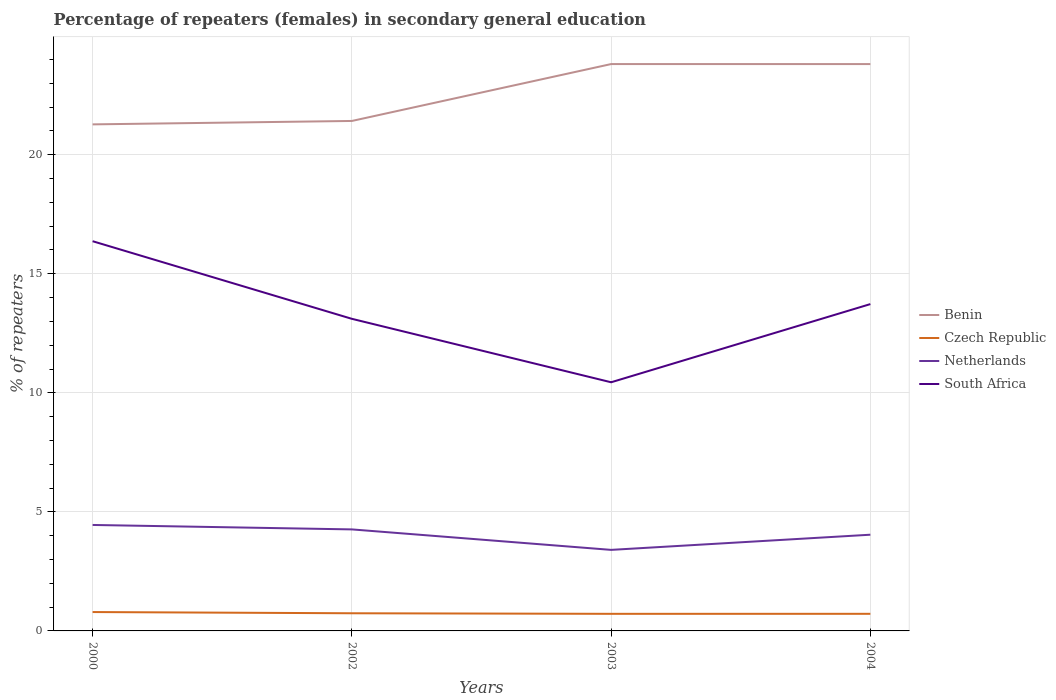Does the line corresponding to Benin intersect with the line corresponding to Netherlands?
Your answer should be compact. No. Across all years, what is the maximum percentage of female repeaters in Benin?
Provide a succinct answer. 21.28. In which year was the percentage of female repeaters in Czech Republic maximum?
Provide a short and direct response. 2003. What is the total percentage of female repeaters in Netherlands in the graph?
Your answer should be compact. 0.22. What is the difference between the highest and the second highest percentage of female repeaters in South Africa?
Keep it short and to the point. 5.93. What is the difference between the highest and the lowest percentage of female repeaters in Netherlands?
Your answer should be compact. 3. How many lines are there?
Offer a very short reply. 4. How many years are there in the graph?
Offer a very short reply. 4. Are the values on the major ticks of Y-axis written in scientific E-notation?
Offer a terse response. No. Where does the legend appear in the graph?
Provide a succinct answer. Center right. How many legend labels are there?
Give a very brief answer. 4. What is the title of the graph?
Your answer should be compact. Percentage of repeaters (females) in secondary general education. What is the label or title of the Y-axis?
Make the answer very short. % of repeaters. What is the % of repeaters in Benin in 2000?
Your answer should be very brief. 21.28. What is the % of repeaters of Czech Republic in 2000?
Provide a succinct answer. 0.79. What is the % of repeaters in Netherlands in 2000?
Your answer should be compact. 4.45. What is the % of repeaters of South Africa in 2000?
Make the answer very short. 16.37. What is the % of repeaters of Benin in 2002?
Provide a succinct answer. 21.42. What is the % of repeaters in Czech Republic in 2002?
Make the answer very short. 0.74. What is the % of repeaters in Netherlands in 2002?
Give a very brief answer. 4.26. What is the % of repeaters of South Africa in 2002?
Ensure brevity in your answer.  13.11. What is the % of repeaters of Benin in 2003?
Your answer should be compact. 23.81. What is the % of repeaters of Czech Republic in 2003?
Your answer should be very brief. 0.72. What is the % of repeaters in Netherlands in 2003?
Provide a short and direct response. 3.4. What is the % of repeaters of South Africa in 2003?
Ensure brevity in your answer.  10.44. What is the % of repeaters in Benin in 2004?
Provide a short and direct response. 23.81. What is the % of repeaters of Czech Republic in 2004?
Provide a succinct answer. 0.72. What is the % of repeaters in Netherlands in 2004?
Ensure brevity in your answer.  4.04. What is the % of repeaters of South Africa in 2004?
Make the answer very short. 13.73. Across all years, what is the maximum % of repeaters in Benin?
Keep it short and to the point. 23.81. Across all years, what is the maximum % of repeaters in Czech Republic?
Offer a terse response. 0.79. Across all years, what is the maximum % of repeaters of Netherlands?
Your answer should be very brief. 4.45. Across all years, what is the maximum % of repeaters in South Africa?
Your response must be concise. 16.37. Across all years, what is the minimum % of repeaters in Benin?
Give a very brief answer. 21.28. Across all years, what is the minimum % of repeaters of Czech Republic?
Ensure brevity in your answer.  0.72. Across all years, what is the minimum % of repeaters in Netherlands?
Provide a short and direct response. 3.4. Across all years, what is the minimum % of repeaters in South Africa?
Your response must be concise. 10.44. What is the total % of repeaters in Benin in the graph?
Provide a short and direct response. 90.31. What is the total % of repeaters in Czech Republic in the graph?
Give a very brief answer. 2.97. What is the total % of repeaters in Netherlands in the graph?
Provide a succinct answer. 16.16. What is the total % of repeaters of South Africa in the graph?
Your response must be concise. 53.65. What is the difference between the % of repeaters of Benin in 2000 and that in 2002?
Provide a short and direct response. -0.14. What is the difference between the % of repeaters in Czech Republic in 2000 and that in 2002?
Provide a succinct answer. 0.05. What is the difference between the % of repeaters in Netherlands in 2000 and that in 2002?
Your response must be concise. 0.19. What is the difference between the % of repeaters of South Africa in 2000 and that in 2002?
Your answer should be very brief. 3.26. What is the difference between the % of repeaters in Benin in 2000 and that in 2003?
Provide a succinct answer. -2.53. What is the difference between the % of repeaters in Czech Republic in 2000 and that in 2003?
Ensure brevity in your answer.  0.07. What is the difference between the % of repeaters of Netherlands in 2000 and that in 2003?
Offer a terse response. 1.05. What is the difference between the % of repeaters in South Africa in 2000 and that in 2003?
Ensure brevity in your answer.  5.93. What is the difference between the % of repeaters of Benin in 2000 and that in 2004?
Your answer should be compact. -2.53. What is the difference between the % of repeaters of Czech Republic in 2000 and that in 2004?
Offer a terse response. 0.07. What is the difference between the % of repeaters in Netherlands in 2000 and that in 2004?
Make the answer very short. 0.41. What is the difference between the % of repeaters of South Africa in 2000 and that in 2004?
Your response must be concise. 2.64. What is the difference between the % of repeaters of Benin in 2002 and that in 2003?
Keep it short and to the point. -2.39. What is the difference between the % of repeaters of Czech Republic in 2002 and that in 2003?
Your answer should be very brief. 0.02. What is the difference between the % of repeaters in Netherlands in 2002 and that in 2003?
Make the answer very short. 0.86. What is the difference between the % of repeaters in South Africa in 2002 and that in 2003?
Make the answer very short. 2.67. What is the difference between the % of repeaters of Benin in 2002 and that in 2004?
Provide a succinct answer. -2.39. What is the difference between the % of repeaters of Czech Republic in 2002 and that in 2004?
Offer a very short reply. 0.02. What is the difference between the % of repeaters in Netherlands in 2002 and that in 2004?
Your answer should be very brief. 0.22. What is the difference between the % of repeaters in South Africa in 2002 and that in 2004?
Ensure brevity in your answer.  -0.62. What is the difference between the % of repeaters of Czech Republic in 2003 and that in 2004?
Your response must be concise. -0. What is the difference between the % of repeaters of Netherlands in 2003 and that in 2004?
Your answer should be very brief. -0.64. What is the difference between the % of repeaters of South Africa in 2003 and that in 2004?
Provide a succinct answer. -3.28. What is the difference between the % of repeaters of Benin in 2000 and the % of repeaters of Czech Republic in 2002?
Your answer should be compact. 20.53. What is the difference between the % of repeaters in Benin in 2000 and the % of repeaters in Netherlands in 2002?
Your response must be concise. 17.01. What is the difference between the % of repeaters of Benin in 2000 and the % of repeaters of South Africa in 2002?
Make the answer very short. 8.17. What is the difference between the % of repeaters of Czech Republic in 2000 and the % of repeaters of Netherlands in 2002?
Offer a very short reply. -3.47. What is the difference between the % of repeaters in Czech Republic in 2000 and the % of repeaters in South Africa in 2002?
Offer a very short reply. -12.32. What is the difference between the % of repeaters in Netherlands in 2000 and the % of repeaters in South Africa in 2002?
Offer a very short reply. -8.66. What is the difference between the % of repeaters in Benin in 2000 and the % of repeaters in Czech Republic in 2003?
Ensure brevity in your answer.  20.56. What is the difference between the % of repeaters in Benin in 2000 and the % of repeaters in Netherlands in 2003?
Your answer should be very brief. 17.87. What is the difference between the % of repeaters of Benin in 2000 and the % of repeaters of South Africa in 2003?
Offer a terse response. 10.83. What is the difference between the % of repeaters of Czech Republic in 2000 and the % of repeaters of Netherlands in 2003?
Offer a very short reply. -2.61. What is the difference between the % of repeaters of Czech Republic in 2000 and the % of repeaters of South Africa in 2003?
Your response must be concise. -9.65. What is the difference between the % of repeaters in Netherlands in 2000 and the % of repeaters in South Africa in 2003?
Make the answer very short. -5.99. What is the difference between the % of repeaters in Benin in 2000 and the % of repeaters in Czech Republic in 2004?
Keep it short and to the point. 20.56. What is the difference between the % of repeaters of Benin in 2000 and the % of repeaters of Netherlands in 2004?
Your answer should be compact. 17.23. What is the difference between the % of repeaters of Benin in 2000 and the % of repeaters of South Africa in 2004?
Provide a short and direct response. 7.55. What is the difference between the % of repeaters of Czech Republic in 2000 and the % of repeaters of Netherlands in 2004?
Your response must be concise. -3.25. What is the difference between the % of repeaters of Czech Republic in 2000 and the % of repeaters of South Africa in 2004?
Offer a very short reply. -12.93. What is the difference between the % of repeaters in Netherlands in 2000 and the % of repeaters in South Africa in 2004?
Ensure brevity in your answer.  -9.28. What is the difference between the % of repeaters in Benin in 2002 and the % of repeaters in Czech Republic in 2003?
Your response must be concise. 20.7. What is the difference between the % of repeaters of Benin in 2002 and the % of repeaters of Netherlands in 2003?
Make the answer very short. 18.02. What is the difference between the % of repeaters of Benin in 2002 and the % of repeaters of South Africa in 2003?
Keep it short and to the point. 10.98. What is the difference between the % of repeaters of Czech Republic in 2002 and the % of repeaters of Netherlands in 2003?
Provide a succinct answer. -2.66. What is the difference between the % of repeaters of Czech Republic in 2002 and the % of repeaters of South Africa in 2003?
Ensure brevity in your answer.  -9.7. What is the difference between the % of repeaters of Netherlands in 2002 and the % of repeaters of South Africa in 2003?
Your answer should be compact. -6.18. What is the difference between the % of repeaters in Benin in 2002 and the % of repeaters in Czech Republic in 2004?
Ensure brevity in your answer.  20.7. What is the difference between the % of repeaters of Benin in 2002 and the % of repeaters of Netherlands in 2004?
Keep it short and to the point. 17.38. What is the difference between the % of repeaters of Benin in 2002 and the % of repeaters of South Africa in 2004?
Offer a terse response. 7.69. What is the difference between the % of repeaters in Czech Republic in 2002 and the % of repeaters in Netherlands in 2004?
Your answer should be compact. -3.3. What is the difference between the % of repeaters in Czech Republic in 2002 and the % of repeaters in South Africa in 2004?
Your response must be concise. -12.99. What is the difference between the % of repeaters in Netherlands in 2002 and the % of repeaters in South Africa in 2004?
Provide a succinct answer. -9.46. What is the difference between the % of repeaters of Benin in 2003 and the % of repeaters of Czech Republic in 2004?
Make the answer very short. 23.09. What is the difference between the % of repeaters in Benin in 2003 and the % of repeaters in Netherlands in 2004?
Give a very brief answer. 19.77. What is the difference between the % of repeaters of Benin in 2003 and the % of repeaters of South Africa in 2004?
Ensure brevity in your answer.  10.08. What is the difference between the % of repeaters in Czech Republic in 2003 and the % of repeaters in Netherlands in 2004?
Your answer should be compact. -3.32. What is the difference between the % of repeaters in Czech Republic in 2003 and the % of repeaters in South Africa in 2004?
Keep it short and to the point. -13.01. What is the difference between the % of repeaters of Netherlands in 2003 and the % of repeaters of South Africa in 2004?
Offer a terse response. -10.32. What is the average % of repeaters of Benin per year?
Offer a terse response. 22.58. What is the average % of repeaters of Czech Republic per year?
Your response must be concise. 0.74. What is the average % of repeaters of Netherlands per year?
Ensure brevity in your answer.  4.04. What is the average % of repeaters of South Africa per year?
Keep it short and to the point. 13.41. In the year 2000, what is the difference between the % of repeaters in Benin and % of repeaters in Czech Republic?
Give a very brief answer. 20.48. In the year 2000, what is the difference between the % of repeaters of Benin and % of repeaters of Netherlands?
Offer a terse response. 16.83. In the year 2000, what is the difference between the % of repeaters in Benin and % of repeaters in South Africa?
Your answer should be very brief. 4.91. In the year 2000, what is the difference between the % of repeaters in Czech Republic and % of repeaters in Netherlands?
Give a very brief answer. -3.66. In the year 2000, what is the difference between the % of repeaters in Czech Republic and % of repeaters in South Africa?
Keep it short and to the point. -15.58. In the year 2000, what is the difference between the % of repeaters of Netherlands and % of repeaters of South Africa?
Give a very brief answer. -11.92. In the year 2002, what is the difference between the % of repeaters in Benin and % of repeaters in Czech Republic?
Offer a very short reply. 20.68. In the year 2002, what is the difference between the % of repeaters of Benin and % of repeaters of Netherlands?
Provide a short and direct response. 17.16. In the year 2002, what is the difference between the % of repeaters of Benin and % of repeaters of South Africa?
Your answer should be compact. 8.31. In the year 2002, what is the difference between the % of repeaters in Czech Republic and % of repeaters in Netherlands?
Your answer should be compact. -3.52. In the year 2002, what is the difference between the % of repeaters in Czech Republic and % of repeaters in South Africa?
Your response must be concise. -12.37. In the year 2002, what is the difference between the % of repeaters of Netherlands and % of repeaters of South Africa?
Give a very brief answer. -8.85. In the year 2003, what is the difference between the % of repeaters in Benin and % of repeaters in Czech Republic?
Ensure brevity in your answer.  23.09. In the year 2003, what is the difference between the % of repeaters of Benin and % of repeaters of Netherlands?
Provide a short and direct response. 20.41. In the year 2003, what is the difference between the % of repeaters of Benin and % of repeaters of South Africa?
Offer a very short reply. 13.37. In the year 2003, what is the difference between the % of repeaters in Czech Republic and % of repeaters in Netherlands?
Ensure brevity in your answer.  -2.69. In the year 2003, what is the difference between the % of repeaters in Czech Republic and % of repeaters in South Africa?
Offer a terse response. -9.73. In the year 2003, what is the difference between the % of repeaters of Netherlands and % of repeaters of South Africa?
Make the answer very short. -7.04. In the year 2004, what is the difference between the % of repeaters in Benin and % of repeaters in Czech Republic?
Provide a short and direct response. 23.09. In the year 2004, what is the difference between the % of repeaters of Benin and % of repeaters of Netherlands?
Your response must be concise. 19.77. In the year 2004, what is the difference between the % of repeaters of Benin and % of repeaters of South Africa?
Offer a terse response. 10.08. In the year 2004, what is the difference between the % of repeaters of Czech Republic and % of repeaters of Netherlands?
Keep it short and to the point. -3.32. In the year 2004, what is the difference between the % of repeaters in Czech Republic and % of repeaters in South Africa?
Offer a terse response. -13.01. In the year 2004, what is the difference between the % of repeaters of Netherlands and % of repeaters of South Africa?
Keep it short and to the point. -9.69. What is the ratio of the % of repeaters in Benin in 2000 to that in 2002?
Ensure brevity in your answer.  0.99. What is the ratio of the % of repeaters in Czech Republic in 2000 to that in 2002?
Make the answer very short. 1.07. What is the ratio of the % of repeaters in Netherlands in 2000 to that in 2002?
Ensure brevity in your answer.  1.04. What is the ratio of the % of repeaters in South Africa in 2000 to that in 2002?
Give a very brief answer. 1.25. What is the ratio of the % of repeaters in Benin in 2000 to that in 2003?
Offer a terse response. 0.89. What is the ratio of the % of repeaters in Czech Republic in 2000 to that in 2003?
Your response must be concise. 1.1. What is the ratio of the % of repeaters of Netherlands in 2000 to that in 2003?
Provide a succinct answer. 1.31. What is the ratio of the % of repeaters in South Africa in 2000 to that in 2003?
Provide a succinct answer. 1.57. What is the ratio of the % of repeaters in Benin in 2000 to that in 2004?
Make the answer very short. 0.89. What is the ratio of the % of repeaters of Czech Republic in 2000 to that in 2004?
Make the answer very short. 1.1. What is the ratio of the % of repeaters of Netherlands in 2000 to that in 2004?
Your answer should be very brief. 1.1. What is the ratio of the % of repeaters in South Africa in 2000 to that in 2004?
Your answer should be compact. 1.19. What is the ratio of the % of repeaters in Benin in 2002 to that in 2003?
Provide a succinct answer. 0.9. What is the ratio of the % of repeaters in Netherlands in 2002 to that in 2003?
Provide a short and direct response. 1.25. What is the ratio of the % of repeaters in South Africa in 2002 to that in 2003?
Give a very brief answer. 1.26. What is the ratio of the % of repeaters in Benin in 2002 to that in 2004?
Give a very brief answer. 0.9. What is the ratio of the % of repeaters in Czech Republic in 2002 to that in 2004?
Offer a very short reply. 1.03. What is the ratio of the % of repeaters in Netherlands in 2002 to that in 2004?
Give a very brief answer. 1.06. What is the ratio of the % of repeaters of South Africa in 2002 to that in 2004?
Ensure brevity in your answer.  0.95. What is the ratio of the % of repeaters of Benin in 2003 to that in 2004?
Give a very brief answer. 1. What is the ratio of the % of repeaters in Netherlands in 2003 to that in 2004?
Make the answer very short. 0.84. What is the ratio of the % of repeaters in South Africa in 2003 to that in 2004?
Your answer should be very brief. 0.76. What is the difference between the highest and the second highest % of repeaters in Czech Republic?
Give a very brief answer. 0.05. What is the difference between the highest and the second highest % of repeaters of Netherlands?
Give a very brief answer. 0.19. What is the difference between the highest and the second highest % of repeaters of South Africa?
Your response must be concise. 2.64. What is the difference between the highest and the lowest % of repeaters in Benin?
Your answer should be compact. 2.53. What is the difference between the highest and the lowest % of repeaters in Czech Republic?
Keep it short and to the point. 0.07. What is the difference between the highest and the lowest % of repeaters of Netherlands?
Provide a short and direct response. 1.05. What is the difference between the highest and the lowest % of repeaters of South Africa?
Offer a very short reply. 5.93. 